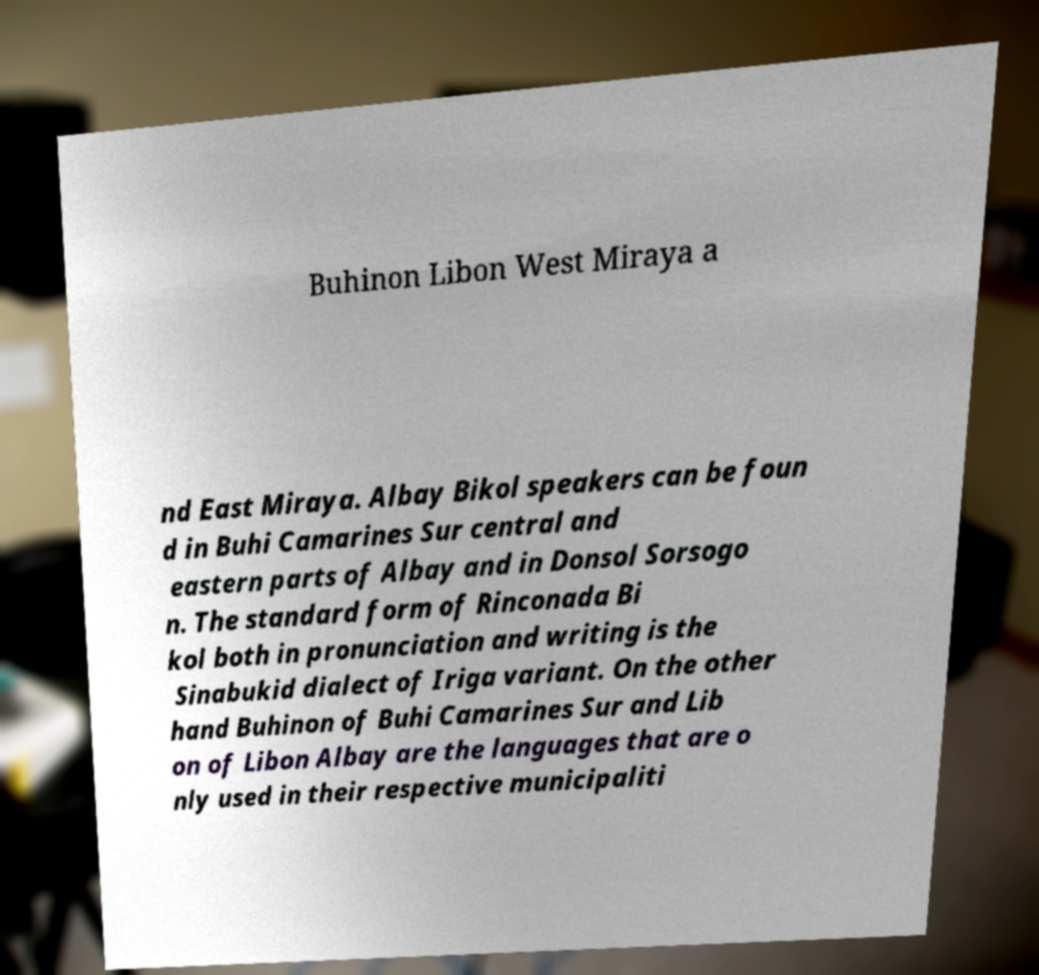Could you assist in decoding the text presented in this image and type it out clearly? Buhinon Libon West Miraya a nd East Miraya. Albay Bikol speakers can be foun d in Buhi Camarines Sur central and eastern parts of Albay and in Donsol Sorsogo n. The standard form of Rinconada Bi kol both in pronunciation and writing is the Sinabukid dialect of Iriga variant. On the other hand Buhinon of Buhi Camarines Sur and Lib on of Libon Albay are the languages that are o nly used in their respective municipaliti 